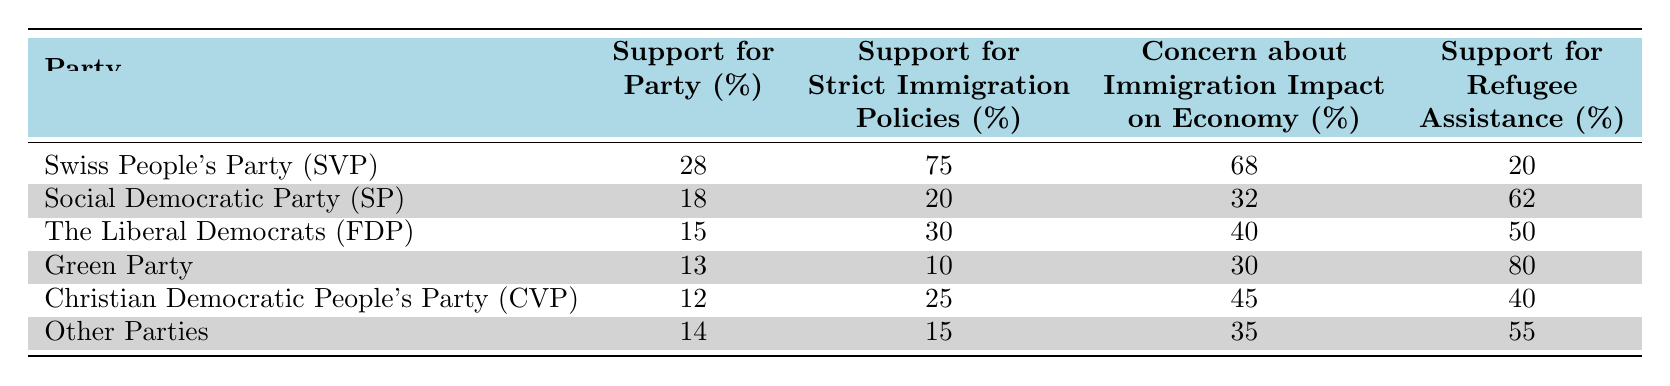What is the support percentage for the Swiss People's Party (SVP)? The table shows that the "Support for Party (%)" for the Swiss People's Party (SVP) is listed directly under the "Support for Party (%)" column. It indicates 28%.
Answer: 28% Which party has the highest support for strict immigration policies? By examining the "Support for Strict Immigration Policies (%)" column, it is clear that the Swiss People's Party (SVP) has the highest support at 75%.
Answer: Swiss People's Party (SVP) What is the average support for refugee assistance across all parties? To find the average, we sum the support for refugee assistance percentages: (20 + 62 + 50 + 80 + 40 + 55) = 307. Then, we divide by the number of parties, which is 6. So, 307 / 6 ≈ 51.17.
Answer: 51.17 Does the Social Democratic Party (SP) have a majority support for strict immigration policies? The support for strict immigration policies for the Social Democratic Party (SP) is 20%, which is below 50%, indicating that they do not have a majority support.
Answer: No Which party has the lowest concern about immigration's impact on the economy? Looking at the "Concern about Immigration Impact on Economy (%)" column, the party with the lowest percentage is the Green Party with 30%.
Answer: Green Party Which party's support for refugee assistance is greater than their support for strict immigration policies? The Green Party has 80% support for refugee assistance compared to 10% for strict immigration policies, which indicates their support for refugee assistance is significantly greater.
Answer: Green Party What is the difference in support for strict immigration policies between the SVP and the SP? The support percentage for SVP is 75%, and for SP is 20%. The difference is calculated by subtracting SP from SVP: 75 - 20 = 55.
Answer: 55 Is it true that all parties have support for strict immigration policies above 10%? By checking the values in the "Support for Strict Immigration Policies (%)" column, we see that the Green Party has support at 10%, making it the only party at this threshold—therefore, not all parties exceed 10%.
Answer: No 